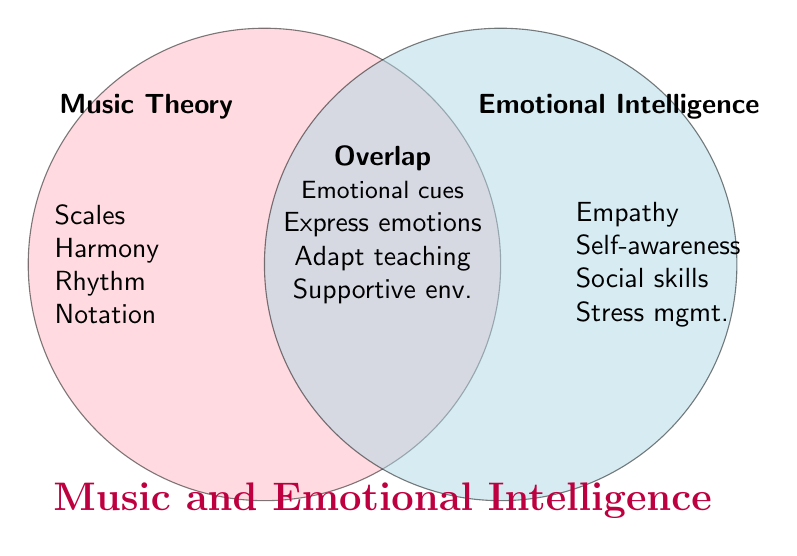What is the title of the figure? The title is located at the bottom of the figure in large, bold text.
Answer: Music and Emotional Intelligence What are the main categories shown in the Venn diagram? The two main categories are labeled near the top of each respective circle.
Answer: Music Theory and Emotional Intelligence How many elements are listed under "Music Theory"? Count all the items under the "Music Theory" label on the left side.
Answer: 4 What elements are in the overlap section of the Venn diagram? Look at the center area of overlap and list the elements mentioned there.
Answer: Emotional cues, Express emotions, Adapt teaching, Supportive env Which category includes "Empathy"? Locate "Empathy" and identify the category it falls under, which is labeled at the top of its circle.
Answer: Emotional Intelligence Which area includes "Adapting teaching style to student needs"? Determine the section of the diagram where this phrase is located.
Answer: Overlap How does "Harmony" relate to Emotional Intelligence, according to the figure? Find "Harmony" and see how it connects to the elements in the overlap section.
Answer: Express emotions Is "Self-awareness" listed in the Music Theory category? Check under the "Music Theory" section to see if "Self-awareness" is listed there.
Answer: No Which category focuses on using music to express emotions? Identify the element that talks about using music to express emotions and determine its category.
Answer: Music Theory Which skills in Emotional Intelligence are depicted in the overlap with Music Theory? Look in the overlap section and identify which elements are related to Emotional Intelligence skills.
Answer: Emotional cues, Express emotions, Adapt teaching, Supportive env 